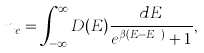Convert formula to latex. <formula><loc_0><loc_0><loc_500><loc_500>n _ { e } = \int _ { - \infty } ^ { \infty } D ( E ) \frac { d E } { e ^ { \beta ( E - E _ { F } ) } + 1 } ,</formula> 